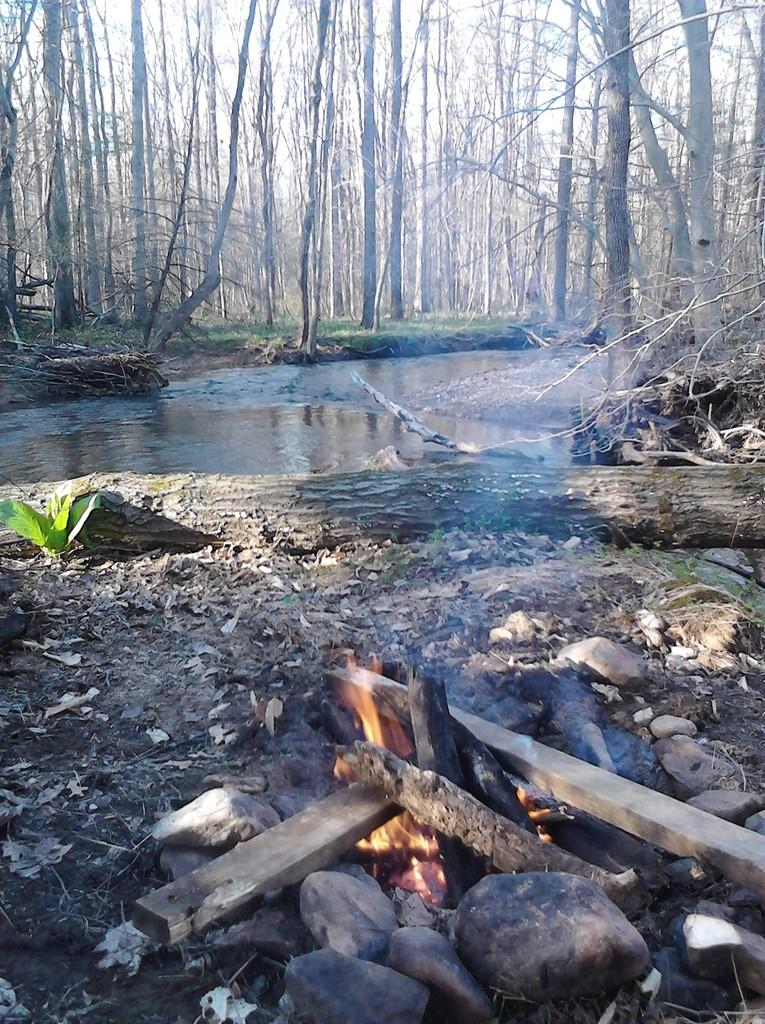What is located at the bottom of the image? There is a campfire at the bottom of the image. What is surrounding the campfire? There are stones around the campfire. What can be seen in the distance in the image? There is a sea visible in the background of the image. What type of vegetation is present in the background of the image? There are trees in the background of the image. What type of fork is being used to stir the campfire? There is no fork present in the image; the campfire is not being stirred. 